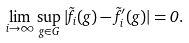Convert formula to latex. <formula><loc_0><loc_0><loc_500><loc_500>\lim _ { i \to \infty } \sup _ { g \in G } | \tilde { f } _ { i } ( g ) - \tilde { f } ^ { \prime } _ { i } ( g ) | = 0 .</formula> 